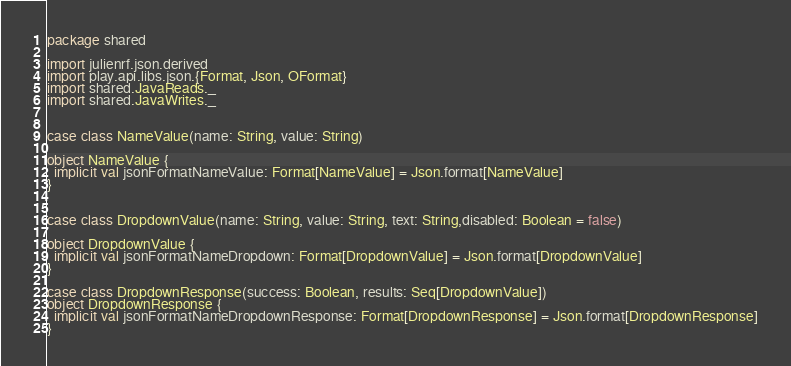<code> <loc_0><loc_0><loc_500><loc_500><_Scala_>package shared

import julienrf.json.derived
import play.api.libs.json.{Format, Json, OFormat}
import shared.JavaReads._
import shared.JavaWrites._


case class NameValue(name: String, value: String)

object NameValue {
  implicit val jsonFormatNameValue: Format[NameValue] = Json.format[NameValue]
}


case class DropdownValue(name: String, value: String, text: String,disabled: Boolean = false)

object DropdownValue {
  implicit val jsonFormatNameDropdown: Format[DropdownValue] = Json.format[DropdownValue]
}

case class DropdownResponse(success: Boolean, results: Seq[DropdownValue])
object DropdownResponse {
  implicit val jsonFormatNameDropdownResponse: Format[DropdownResponse] = Json.format[DropdownResponse]
}

</code> 